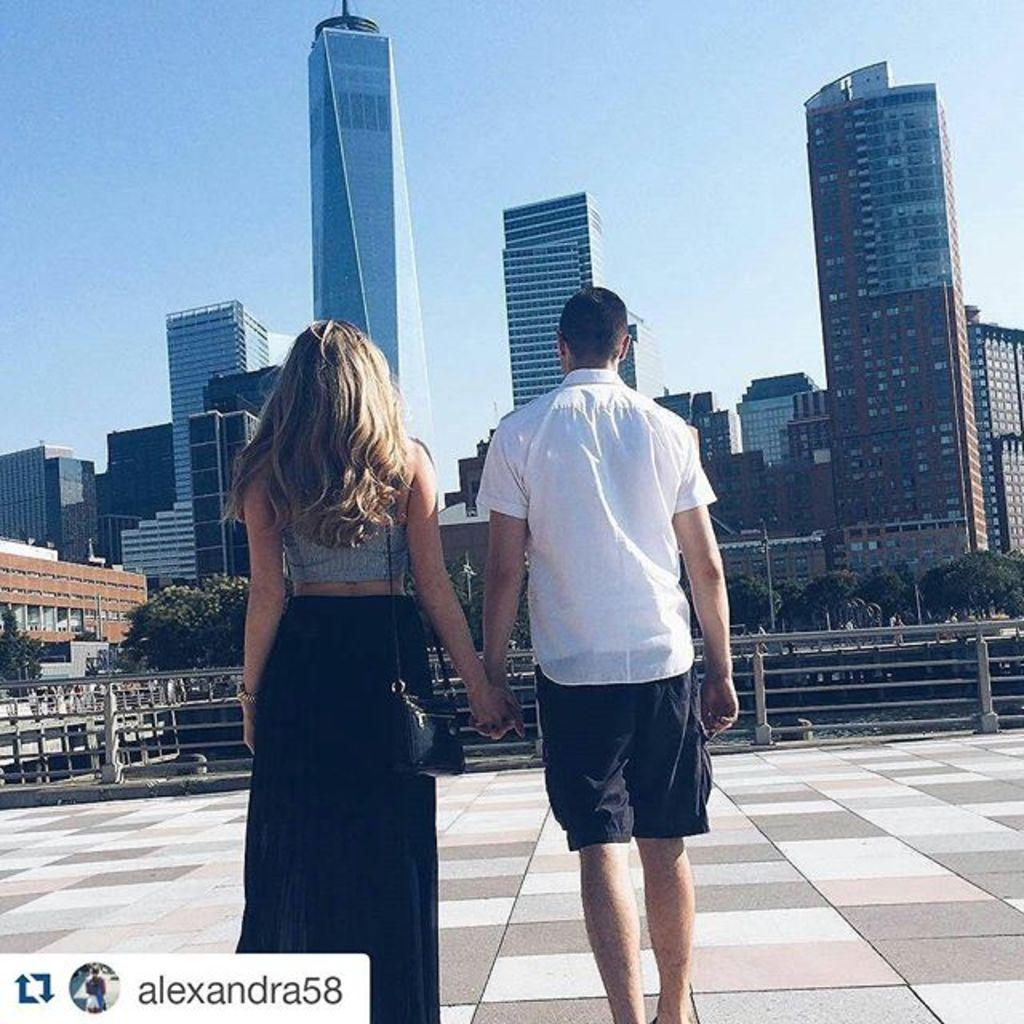How many people are in the foreground of the image? There are two people standing in the foreground of the image. What is located behind the people? There is a railing behind the people. What can be seen beyond the railing? Trees are visible behind the railing. What type of structures are in the background of the image? There are huge buildings in the background of the image. What type of drink is being served at the harbor in the image? There is no harbor or drink present in the image. What operation is being performed on the buildings in the background? There is no operation being performed on the buildings in the background; they are simply visible in the image. 